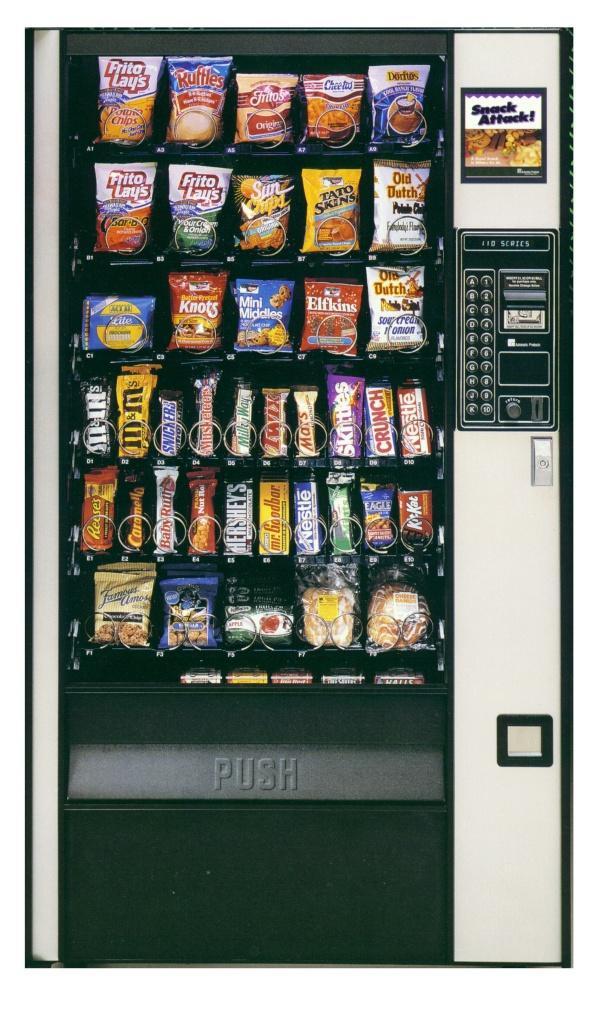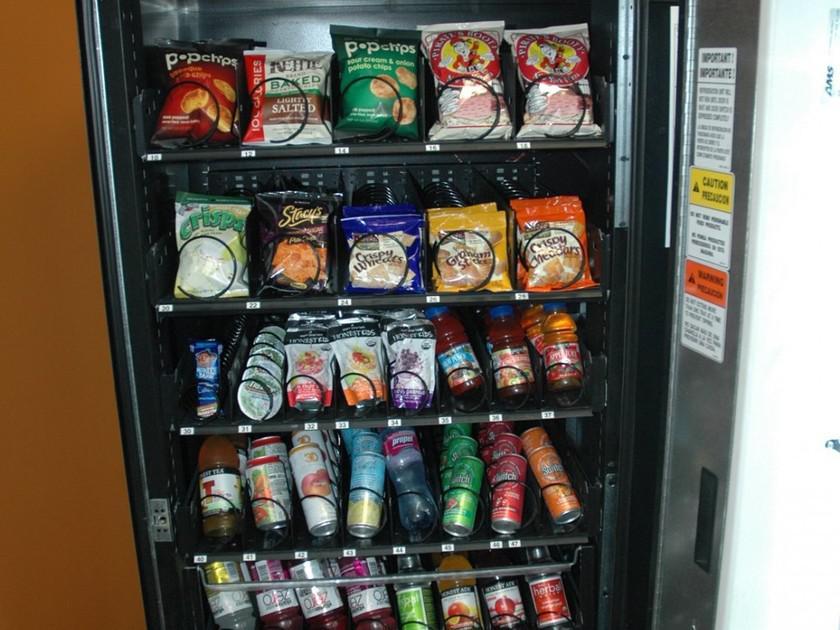The first image is the image on the left, the second image is the image on the right. Assess this claim about the two images: "A part of a human being's body is near a vending machine.". Correct or not? Answer yes or no. No. The first image is the image on the left, the second image is the image on the right. Evaluate the accuracy of this statement regarding the images: "Left image shows one vending machine displayed straight-on instead of at any angle.". Is it true? Answer yes or no. Yes. 